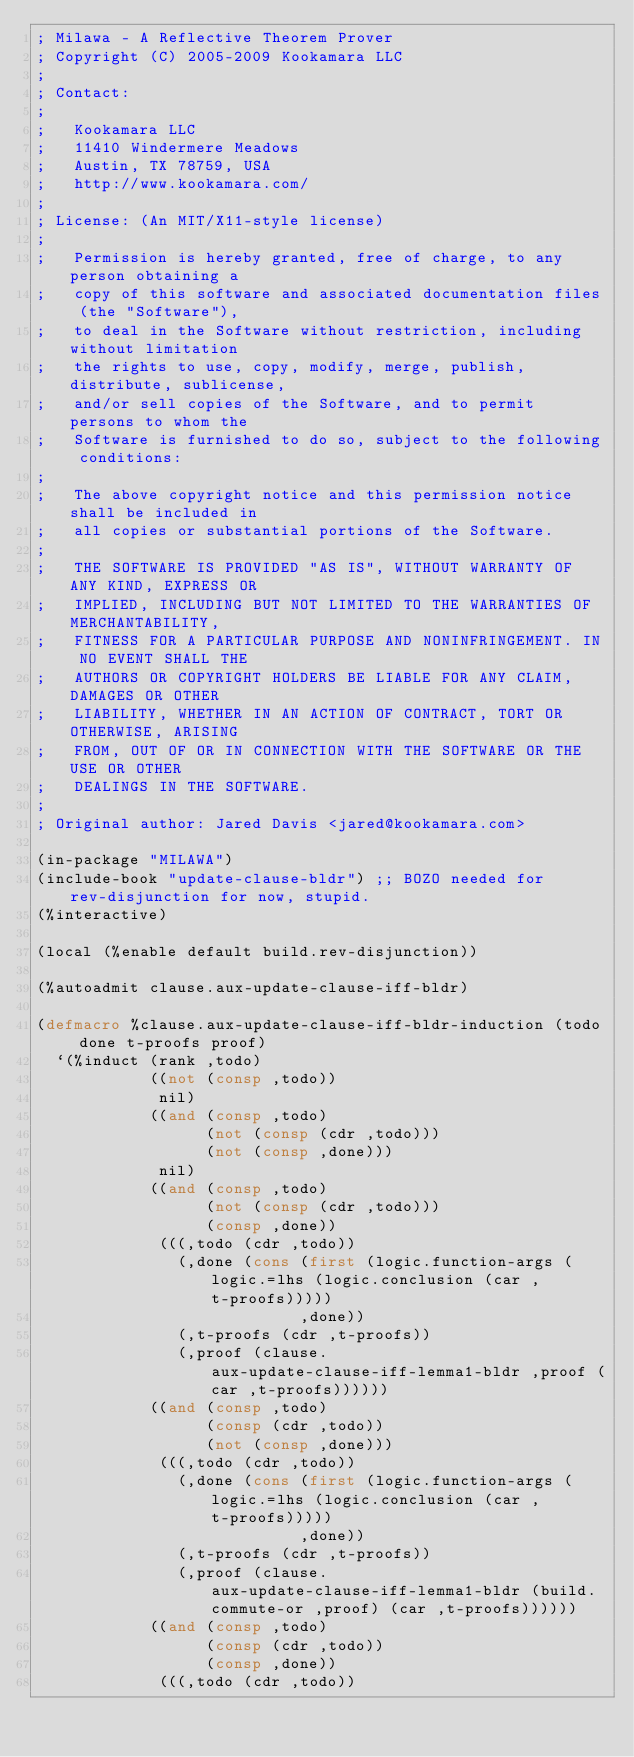Convert code to text. <code><loc_0><loc_0><loc_500><loc_500><_Lisp_>; Milawa - A Reflective Theorem Prover
; Copyright (C) 2005-2009 Kookamara LLC
;
; Contact:
;
;   Kookamara LLC
;   11410 Windermere Meadows
;   Austin, TX 78759, USA
;   http://www.kookamara.com/
;
; License: (An MIT/X11-style license)
;
;   Permission is hereby granted, free of charge, to any person obtaining a
;   copy of this software and associated documentation files (the "Software"),
;   to deal in the Software without restriction, including without limitation
;   the rights to use, copy, modify, merge, publish, distribute, sublicense,
;   and/or sell copies of the Software, and to permit persons to whom the
;   Software is furnished to do so, subject to the following conditions:
;
;   The above copyright notice and this permission notice shall be included in
;   all copies or substantial portions of the Software.
;
;   THE SOFTWARE IS PROVIDED "AS IS", WITHOUT WARRANTY OF ANY KIND, EXPRESS OR
;   IMPLIED, INCLUDING BUT NOT LIMITED TO THE WARRANTIES OF MERCHANTABILITY,
;   FITNESS FOR A PARTICULAR PURPOSE AND NONINFRINGEMENT. IN NO EVENT SHALL THE
;   AUTHORS OR COPYRIGHT HOLDERS BE LIABLE FOR ANY CLAIM, DAMAGES OR OTHER
;   LIABILITY, WHETHER IN AN ACTION OF CONTRACT, TORT OR OTHERWISE, ARISING
;   FROM, OUT OF OR IN CONNECTION WITH THE SOFTWARE OR THE USE OR OTHER
;   DEALINGS IN THE SOFTWARE.
;
; Original author: Jared Davis <jared@kookamara.com>

(in-package "MILAWA")
(include-book "update-clause-bldr") ;; BOZO needed for rev-disjunction for now, stupid.
(%interactive)

(local (%enable default build.rev-disjunction))

(%autoadmit clause.aux-update-clause-iff-bldr)

(defmacro %clause.aux-update-clause-iff-bldr-induction (todo done t-proofs proof)
  `(%induct (rank ,todo)
            ((not (consp ,todo))
             nil)
            ((and (consp ,todo)
                  (not (consp (cdr ,todo)))
                  (not (consp ,done)))
             nil)
            ((and (consp ,todo)
                  (not (consp (cdr ,todo)))
                  (consp ,done))
             (((,todo (cdr ,todo))
               (,done (cons (first (logic.function-args (logic.=lhs (logic.conclusion (car ,t-proofs)))))
                            ,done))
               (,t-proofs (cdr ,t-proofs))
               (,proof (clause.aux-update-clause-iff-lemma1-bldr ,proof (car ,t-proofs))))))
            ((and (consp ,todo)
                  (consp (cdr ,todo))
                  (not (consp ,done)))
             (((,todo (cdr ,todo))
               (,done (cons (first (logic.function-args (logic.=lhs (logic.conclusion (car ,t-proofs)))))
                            ,done))
               (,t-proofs (cdr ,t-proofs))
               (,proof (clause.aux-update-clause-iff-lemma1-bldr (build.commute-or ,proof) (car ,t-proofs))))))
            ((and (consp ,todo)
                  (consp (cdr ,todo))
                  (consp ,done))
             (((,todo (cdr ,todo))</code> 